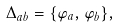Convert formula to latex. <formula><loc_0><loc_0><loc_500><loc_500>\Delta _ { a b } = \{ \varphi _ { a } , \varphi _ { b } \} ,</formula> 